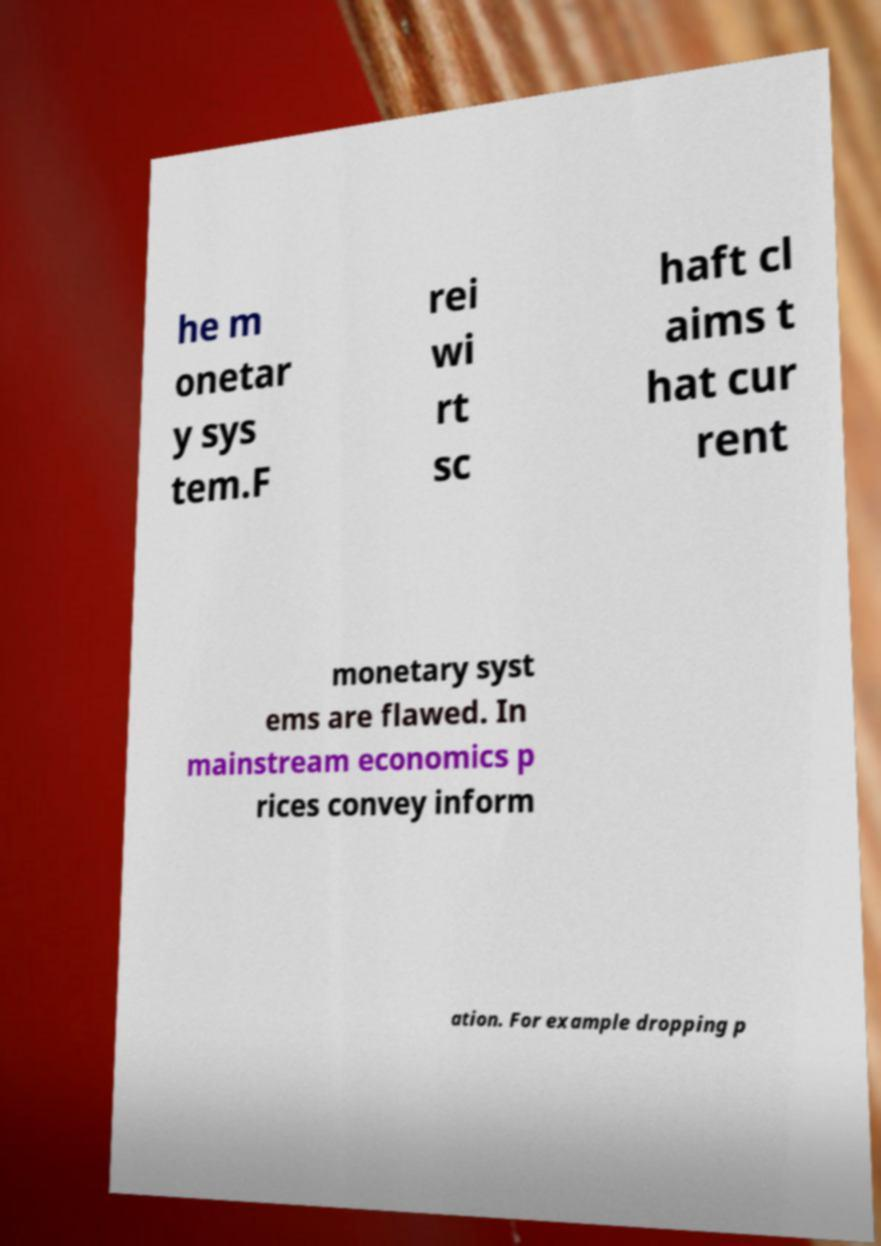Can you read and provide the text displayed in the image?This photo seems to have some interesting text. Can you extract and type it out for me? he m onetar y sys tem.F rei wi rt sc haft cl aims t hat cur rent monetary syst ems are flawed. In mainstream economics p rices convey inform ation. For example dropping p 